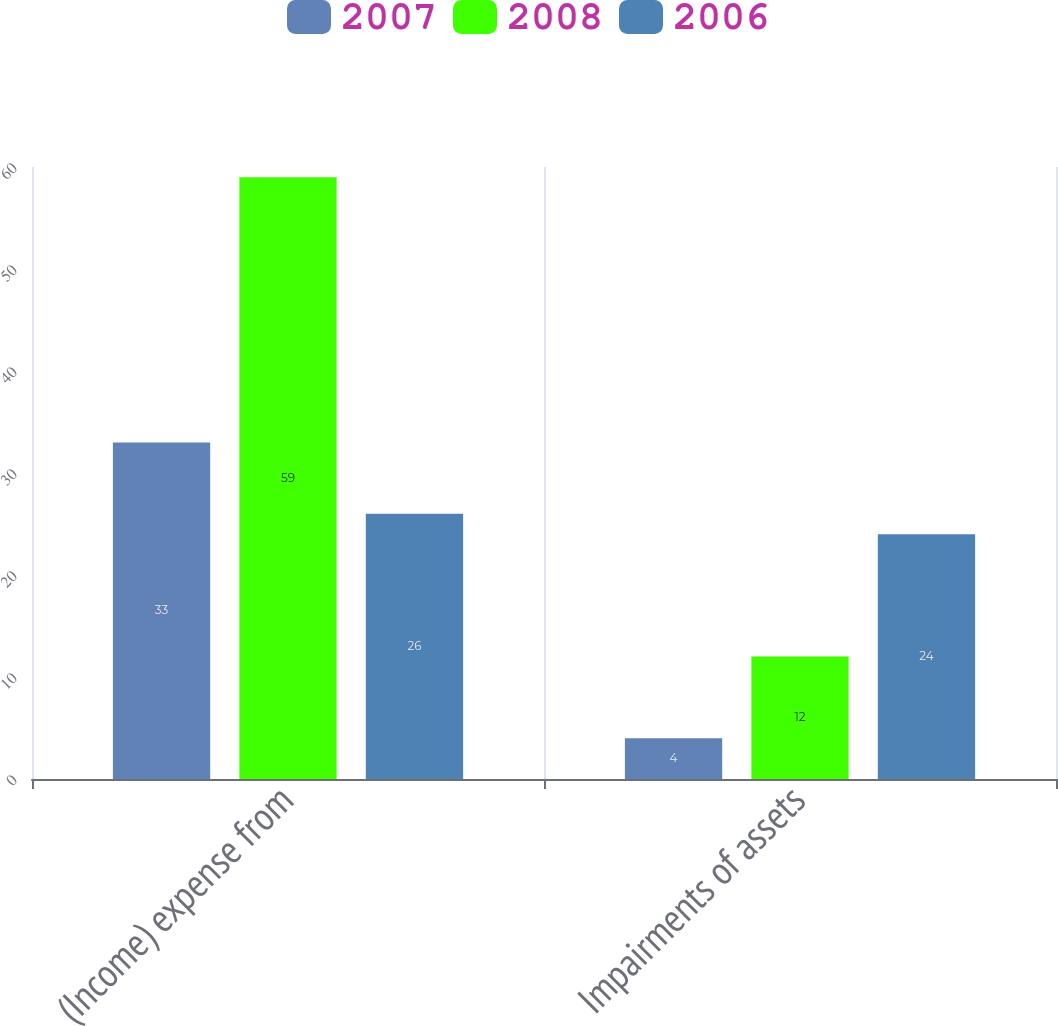<chart> <loc_0><loc_0><loc_500><loc_500><stacked_bar_chart><ecel><fcel>(Income) expense from<fcel>Impairments of assets<nl><fcel>2007<fcel>33<fcel>4<nl><fcel>2008<fcel>59<fcel>12<nl><fcel>2006<fcel>26<fcel>24<nl></chart> 